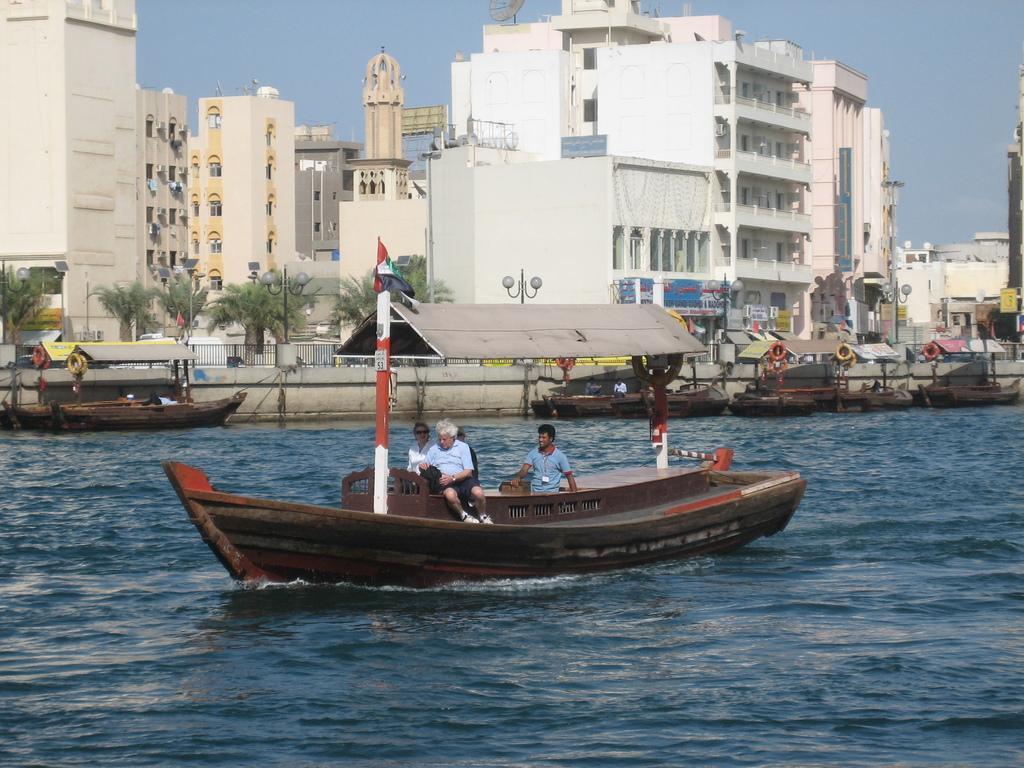Describe this image in one or two sentences. In the image there are few persons sitting on a boat in the lake and behind them there are few boats, over the back there are buildings in front of trees and above its sky. 